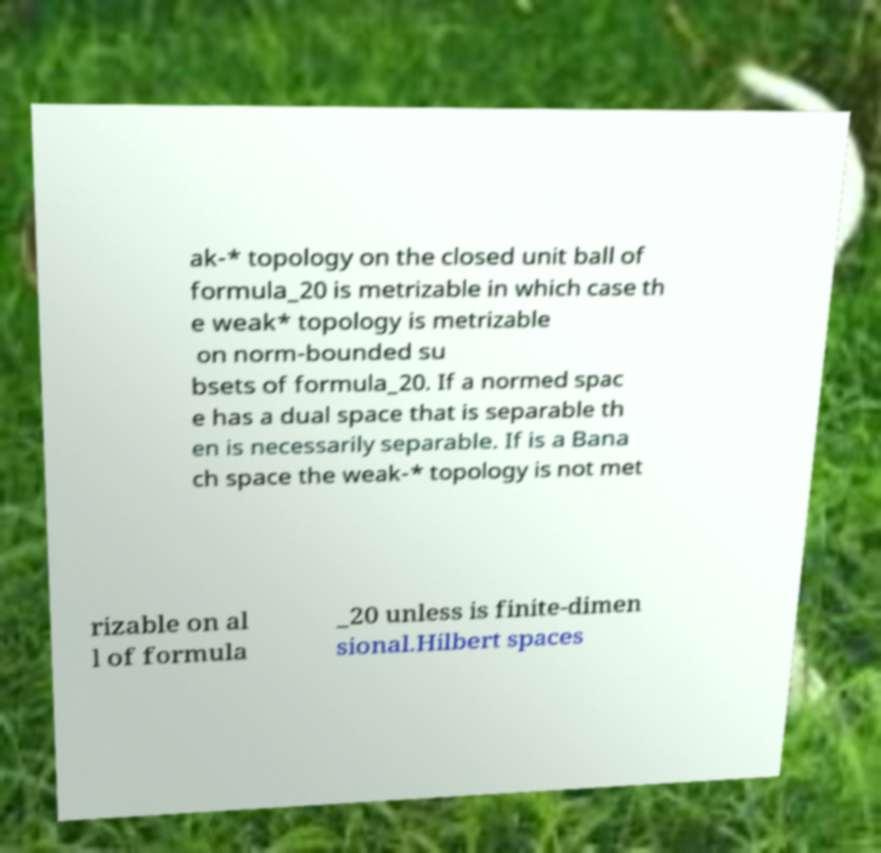Could you assist in decoding the text presented in this image and type it out clearly? ak-* topology on the closed unit ball of formula_20 is metrizable in which case th e weak* topology is metrizable on norm-bounded su bsets of formula_20. If a normed spac e has a dual space that is separable th en is necessarily separable. If is a Bana ch space the weak-* topology is not met rizable on al l of formula _20 unless is finite-dimen sional.Hilbert spaces 